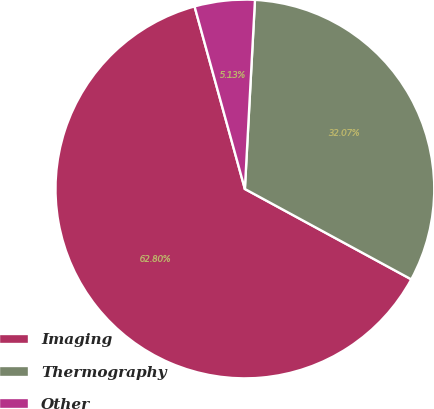Convert chart to OTSL. <chart><loc_0><loc_0><loc_500><loc_500><pie_chart><fcel>Imaging<fcel>Thermography<fcel>Other<nl><fcel>62.8%<fcel>32.07%<fcel>5.13%<nl></chart> 